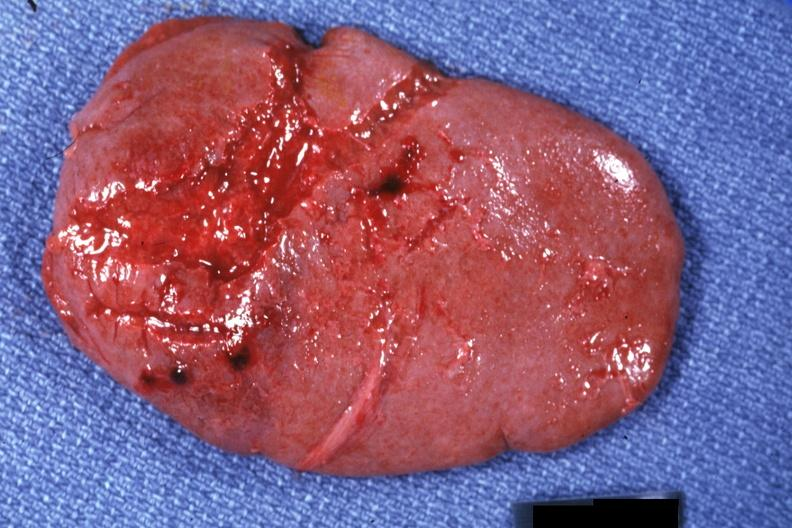s traumatic rupture present?
Answer the question using a single word or phrase. Yes 